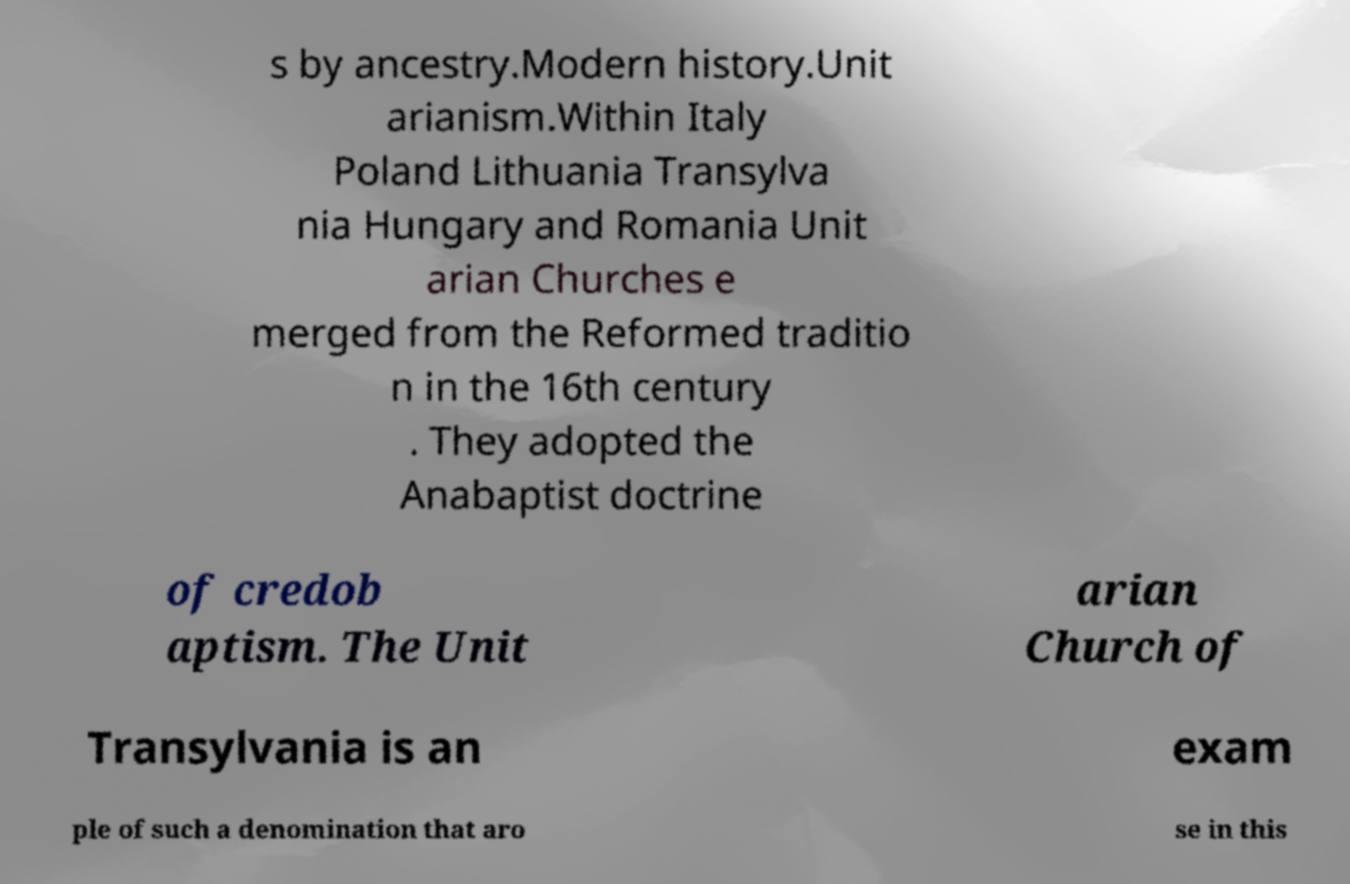Could you extract and type out the text from this image? s by ancestry.Modern history.Unit arianism.Within Italy Poland Lithuania Transylva nia Hungary and Romania Unit arian Churches e merged from the Reformed traditio n in the 16th century . They adopted the Anabaptist doctrine of credob aptism. The Unit arian Church of Transylvania is an exam ple of such a denomination that aro se in this 